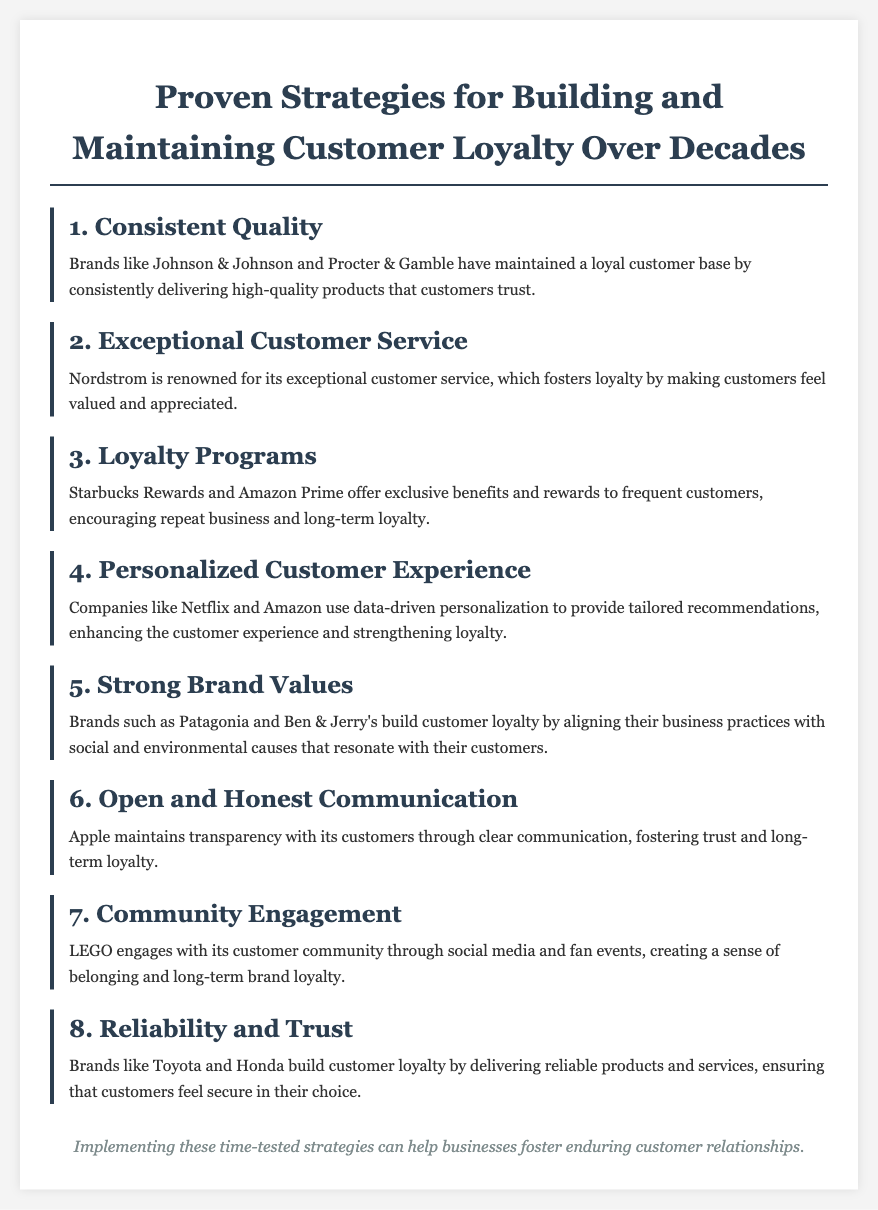what is the first strategy for building customer loyalty? The first strategy mentioned in the document for building customer loyalty is "Consistent Quality."
Answer: Consistent Quality which brand is known for exceptional customer service? The document states that "Nordstrom" is renowned for its exceptional customer service.
Answer: Nordstrom name a loyalty program mentioned in the document. The document lists "Starbucks Rewards" as one of the loyalty programs.
Answer: Starbucks Rewards which company uses data-driven personalization? The document mentions "Netflix" as a company that uses data-driven personalization.
Answer: Netflix what is the seventh strategy listed in the document? The seventh strategy described in the document is "Community Engagement."
Answer: Community Engagement how do brands like Patagonia build customer loyalty? The document states that brands like Patagonia build loyalty through alignment with social and environmental causes.
Answer: Social and environmental causes which two brands are associated with reliability and trust? The document refers to "Toyota and Honda" as brands that build customer loyalty through reliability.
Answer: Toyota and Honda what element reinforces openness and honesty in communication according to the document? The document states that Apple maintains transparency through "clear communication."
Answer: Clear communication who engages with the customer community through social media? The document indicates that "LEGO" engages with its customer community through social media.
Answer: LEGO 